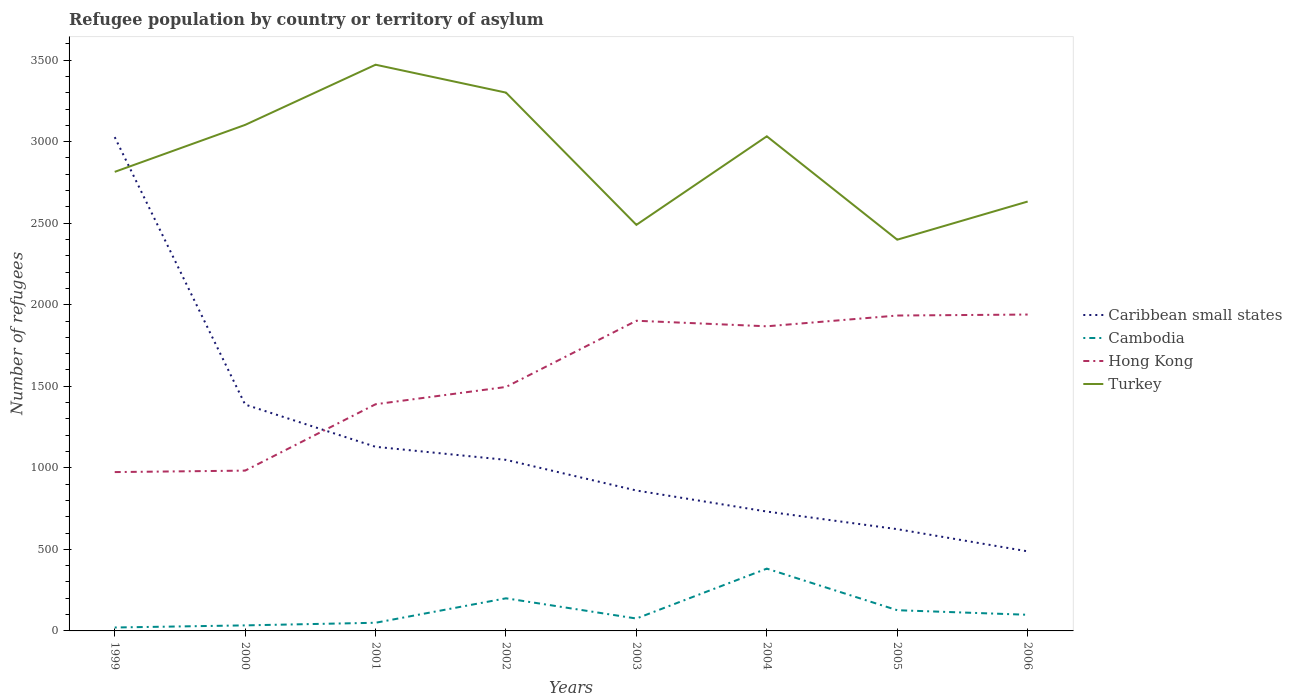Does the line corresponding to Turkey intersect with the line corresponding to Caribbean small states?
Offer a terse response. Yes. Is the number of lines equal to the number of legend labels?
Keep it short and to the point. Yes. Across all years, what is the maximum number of refugees in Cambodia?
Offer a terse response. 21. In which year was the number of refugees in Cambodia maximum?
Ensure brevity in your answer.  1999. What is the total number of refugees in Hong Kong in the graph?
Provide a succinct answer. -38. What is the difference between the highest and the second highest number of refugees in Cambodia?
Make the answer very short. 361. What is the difference between the highest and the lowest number of refugees in Hong Kong?
Give a very brief answer. 4. Is the number of refugees in Hong Kong strictly greater than the number of refugees in Caribbean small states over the years?
Give a very brief answer. No. How many lines are there?
Give a very brief answer. 4. How many years are there in the graph?
Keep it short and to the point. 8. How are the legend labels stacked?
Provide a succinct answer. Vertical. What is the title of the graph?
Your response must be concise. Refugee population by country or territory of asylum. What is the label or title of the X-axis?
Give a very brief answer. Years. What is the label or title of the Y-axis?
Ensure brevity in your answer.  Number of refugees. What is the Number of refugees of Caribbean small states in 1999?
Provide a short and direct response. 3028. What is the Number of refugees in Cambodia in 1999?
Your answer should be compact. 21. What is the Number of refugees of Hong Kong in 1999?
Ensure brevity in your answer.  974. What is the Number of refugees in Turkey in 1999?
Provide a succinct answer. 2815. What is the Number of refugees of Caribbean small states in 2000?
Provide a succinct answer. 1388. What is the Number of refugees in Hong Kong in 2000?
Keep it short and to the point. 983. What is the Number of refugees in Turkey in 2000?
Your response must be concise. 3103. What is the Number of refugees of Caribbean small states in 2001?
Ensure brevity in your answer.  1129. What is the Number of refugees of Hong Kong in 2001?
Give a very brief answer. 1390. What is the Number of refugees of Turkey in 2001?
Your answer should be very brief. 3472. What is the Number of refugees in Caribbean small states in 2002?
Provide a short and direct response. 1049. What is the Number of refugees in Hong Kong in 2002?
Your answer should be very brief. 1496. What is the Number of refugees of Turkey in 2002?
Provide a succinct answer. 3301. What is the Number of refugees of Caribbean small states in 2003?
Provide a short and direct response. 861. What is the Number of refugees in Cambodia in 2003?
Your answer should be very brief. 76. What is the Number of refugees of Hong Kong in 2003?
Provide a succinct answer. 1902. What is the Number of refugees in Turkey in 2003?
Offer a very short reply. 2490. What is the Number of refugees of Caribbean small states in 2004?
Your response must be concise. 732. What is the Number of refugees in Cambodia in 2004?
Keep it short and to the point. 382. What is the Number of refugees of Hong Kong in 2004?
Ensure brevity in your answer.  1868. What is the Number of refugees in Turkey in 2004?
Ensure brevity in your answer.  3033. What is the Number of refugees of Caribbean small states in 2005?
Your answer should be very brief. 624. What is the Number of refugees in Cambodia in 2005?
Give a very brief answer. 127. What is the Number of refugees in Hong Kong in 2005?
Offer a very short reply. 1934. What is the Number of refugees of Turkey in 2005?
Ensure brevity in your answer.  2399. What is the Number of refugees in Caribbean small states in 2006?
Provide a short and direct response. 488. What is the Number of refugees of Cambodia in 2006?
Provide a succinct answer. 99. What is the Number of refugees of Hong Kong in 2006?
Keep it short and to the point. 1940. What is the Number of refugees of Turkey in 2006?
Make the answer very short. 2633. Across all years, what is the maximum Number of refugees in Caribbean small states?
Provide a succinct answer. 3028. Across all years, what is the maximum Number of refugees of Cambodia?
Provide a short and direct response. 382. Across all years, what is the maximum Number of refugees of Hong Kong?
Offer a very short reply. 1940. Across all years, what is the maximum Number of refugees of Turkey?
Your response must be concise. 3472. Across all years, what is the minimum Number of refugees in Caribbean small states?
Ensure brevity in your answer.  488. Across all years, what is the minimum Number of refugees of Hong Kong?
Offer a terse response. 974. Across all years, what is the minimum Number of refugees of Turkey?
Give a very brief answer. 2399. What is the total Number of refugees of Caribbean small states in the graph?
Ensure brevity in your answer.  9299. What is the total Number of refugees in Cambodia in the graph?
Your answer should be very brief. 989. What is the total Number of refugees of Hong Kong in the graph?
Provide a succinct answer. 1.25e+04. What is the total Number of refugees in Turkey in the graph?
Your response must be concise. 2.32e+04. What is the difference between the Number of refugees in Caribbean small states in 1999 and that in 2000?
Offer a terse response. 1640. What is the difference between the Number of refugees in Hong Kong in 1999 and that in 2000?
Ensure brevity in your answer.  -9. What is the difference between the Number of refugees of Turkey in 1999 and that in 2000?
Provide a short and direct response. -288. What is the difference between the Number of refugees in Caribbean small states in 1999 and that in 2001?
Provide a short and direct response. 1899. What is the difference between the Number of refugees in Hong Kong in 1999 and that in 2001?
Your response must be concise. -416. What is the difference between the Number of refugees of Turkey in 1999 and that in 2001?
Make the answer very short. -657. What is the difference between the Number of refugees of Caribbean small states in 1999 and that in 2002?
Your response must be concise. 1979. What is the difference between the Number of refugees in Cambodia in 1999 and that in 2002?
Your answer should be compact. -179. What is the difference between the Number of refugees in Hong Kong in 1999 and that in 2002?
Your answer should be very brief. -522. What is the difference between the Number of refugees in Turkey in 1999 and that in 2002?
Your response must be concise. -486. What is the difference between the Number of refugees of Caribbean small states in 1999 and that in 2003?
Keep it short and to the point. 2167. What is the difference between the Number of refugees in Cambodia in 1999 and that in 2003?
Provide a succinct answer. -55. What is the difference between the Number of refugees of Hong Kong in 1999 and that in 2003?
Provide a succinct answer. -928. What is the difference between the Number of refugees of Turkey in 1999 and that in 2003?
Provide a short and direct response. 325. What is the difference between the Number of refugees of Caribbean small states in 1999 and that in 2004?
Provide a succinct answer. 2296. What is the difference between the Number of refugees of Cambodia in 1999 and that in 2004?
Your response must be concise. -361. What is the difference between the Number of refugees in Hong Kong in 1999 and that in 2004?
Provide a short and direct response. -894. What is the difference between the Number of refugees of Turkey in 1999 and that in 2004?
Keep it short and to the point. -218. What is the difference between the Number of refugees of Caribbean small states in 1999 and that in 2005?
Keep it short and to the point. 2404. What is the difference between the Number of refugees in Cambodia in 1999 and that in 2005?
Make the answer very short. -106. What is the difference between the Number of refugees in Hong Kong in 1999 and that in 2005?
Ensure brevity in your answer.  -960. What is the difference between the Number of refugees in Turkey in 1999 and that in 2005?
Offer a terse response. 416. What is the difference between the Number of refugees of Caribbean small states in 1999 and that in 2006?
Provide a short and direct response. 2540. What is the difference between the Number of refugees of Cambodia in 1999 and that in 2006?
Ensure brevity in your answer.  -78. What is the difference between the Number of refugees in Hong Kong in 1999 and that in 2006?
Give a very brief answer. -966. What is the difference between the Number of refugees of Turkey in 1999 and that in 2006?
Give a very brief answer. 182. What is the difference between the Number of refugees of Caribbean small states in 2000 and that in 2001?
Provide a succinct answer. 259. What is the difference between the Number of refugees in Cambodia in 2000 and that in 2001?
Give a very brief answer. -16. What is the difference between the Number of refugees in Hong Kong in 2000 and that in 2001?
Offer a very short reply. -407. What is the difference between the Number of refugees of Turkey in 2000 and that in 2001?
Provide a succinct answer. -369. What is the difference between the Number of refugees in Caribbean small states in 2000 and that in 2002?
Ensure brevity in your answer.  339. What is the difference between the Number of refugees of Cambodia in 2000 and that in 2002?
Your answer should be compact. -166. What is the difference between the Number of refugees in Hong Kong in 2000 and that in 2002?
Your response must be concise. -513. What is the difference between the Number of refugees in Turkey in 2000 and that in 2002?
Give a very brief answer. -198. What is the difference between the Number of refugees of Caribbean small states in 2000 and that in 2003?
Offer a terse response. 527. What is the difference between the Number of refugees of Cambodia in 2000 and that in 2003?
Your answer should be compact. -42. What is the difference between the Number of refugees of Hong Kong in 2000 and that in 2003?
Your answer should be compact. -919. What is the difference between the Number of refugees of Turkey in 2000 and that in 2003?
Offer a very short reply. 613. What is the difference between the Number of refugees in Caribbean small states in 2000 and that in 2004?
Provide a succinct answer. 656. What is the difference between the Number of refugees in Cambodia in 2000 and that in 2004?
Your answer should be very brief. -348. What is the difference between the Number of refugees of Hong Kong in 2000 and that in 2004?
Offer a terse response. -885. What is the difference between the Number of refugees of Turkey in 2000 and that in 2004?
Your answer should be compact. 70. What is the difference between the Number of refugees in Caribbean small states in 2000 and that in 2005?
Provide a short and direct response. 764. What is the difference between the Number of refugees in Cambodia in 2000 and that in 2005?
Your answer should be very brief. -93. What is the difference between the Number of refugees of Hong Kong in 2000 and that in 2005?
Your answer should be compact. -951. What is the difference between the Number of refugees in Turkey in 2000 and that in 2005?
Your answer should be compact. 704. What is the difference between the Number of refugees in Caribbean small states in 2000 and that in 2006?
Make the answer very short. 900. What is the difference between the Number of refugees in Cambodia in 2000 and that in 2006?
Ensure brevity in your answer.  -65. What is the difference between the Number of refugees of Hong Kong in 2000 and that in 2006?
Provide a short and direct response. -957. What is the difference between the Number of refugees of Turkey in 2000 and that in 2006?
Your answer should be very brief. 470. What is the difference between the Number of refugees of Cambodia in 2001 and that in 2002?
Your answer should be compact. -150. What is the difference between the Number of refugees of Hong Kong in 2001 and that in 2002?
Your answer should be very brief. -106. What is the difference between the Number of refugees of Turkey in 2001 and that in 2002?
Your answer should be compact. 171. What is the difference between the Number of refugees of Caribbean small states in 2001 and that in 2003?
Offer a terse response. 268. What is the difference between the Number of refugees of Cambodia in 2001 and that in 2003?
Provide a succinct answer. -26. What is the difference between the Number of refugees of Hong Kong in 2001 and that in 2003?
Provide a short and direct response. -512. What is the difference between the Number of refugees of Turkey in 2001 and that in 2003?
Make the answer very short. 982. What is the difference between the Number of refugees of Caribbean small states in 2001 and that in 2004?
Your response must be concise. 397. What is the difference between the Number of refugees of Cambodia in 2001 and that in 2004?
Your answer should be very brief. -332. What is the difference between the Number of refugees in Hong Kong in 2001 and that in 2004?
Provide a succinct answer. -478. What is the difference between the Number of refugees in Turkey in 2001 and that in 2004?
Ensure brevity in your answer.  439. What is the difference between the Number of refugees in Caribbean small states in 2001 and that in 2005?
Offer a terse response. 505. What is the difference between the Number of refugees in Cambodia in 2001 and that in 2005?
Keep it short and to the point. -77. What is the difference between the Number of refugees in Hong Kong in 2001 and that in 2005?
Offer a very short reply. -544. What is the difference between the Number of refugees in Turkey in 2001 and that in 2005?
Your answer should be compact. 1073. What is the difference between the Number of refugees of Caribbean small states in 2001 and that in 2006?
Provide a succinct answer. 641. What is the difference between the Number of refugees of Cambodia in 2001 and that in 2006?
Your answer should be compact. -49. What is the difference between the Number of refugees of Hong Kong in 2001 and that in 2006?
Your answer should be very brief. -550. What is the difference between the Number of refugees in Turkey in 2001 and that in 2006?
Keep it short and to the point. 839. What is the difference between the Number of refugees in Caribbean small states in 2002 and that in 2003?
Keep it short and to the point. 188. What is the difference between the Number of refugees of Cambodia in 2002 and that in 2003?
Offer a terse response. 124. What is the difference between the Number of refugees of Hong Kong in 2002 and that in 2003?
Provide a short and direct response. -406. What is the difference between the Number of refugees in Turkey in 2002 and that in 2003?
Offer a terse response. 811. What is the difference between the Number of refugees of Caribbean small states in 2002 and that in 2004?
Your answer should be compact. 317. What is the difference between the Number of refugees of Cambodia in 2002 and that in 2004?
Offer a terse response. -182. What is the difference between the Number of refugees of Hong Kong in 2002 and that in 2004?
Make the answer very short. -372. What is the difference between the Number of refugees in Turkey in 2002 and that in 2004?
Offer a terse response. 268. What is the difference between the Number of refugees in Caribbean small states in 2002 and that in 2005?
Make the answer very short. 425. What is the difference between the Number of refugees in Cambodia in 2002 and that in 2005?
Offer a terse response. 73. What is the difference between the Number of refugees in Hong Kong in 2002 and that in 2005?
Keep it short and to the point. -438. What is the difference between the Number of refugees of Turkey in 2002 and that in 2005?
Offer a terse response. 902. What is the difference between the Number of refugees in Caribbean small states in 2002 and that in 2006?
Your answer should be very brief. 561. What is the difference between the Number of refugees of Cambodia in 2002 and that in 2006?
Provide a succinct answer. 101. What is the difference between the Number of refugees of Hong Kong in 2002 and that in 2006?
Keep it short and to the point. -444. What is the difference between the Number of refugees of Turkey in 2002 and that in 2006?
Offer a terse response. 668. What is the difference between the Number of refugees in Caribbean small states in 2003 and that in 2004?
Offer a terse response. 129. What is the difference between the Number of refugees of Cambodia in 2003 and that in 2004?
Your response must be concise. -306. What is the difference between the Number of refugees of Turkey in 2003 and that in 2004?
Ensure brevity in your answer.  -543. What is the difference between the Number of refugees in Caribbean small states in 2003 and that in 2005?
Provide a short and direct response. 237. What is the difference between the Number of refugees in Cambodia in 2003 and that in 2005?
Provide a succinct answer. -51. What is the difference between the Number of refugees of Hong Kong in 2003 and that in 2005?
Your answer should be compact. -32. What is the difference between the Number of refugees of Turkey in 2003 and that in 2005?
Offer a very short reply. 91. What is the difference between the Number of refugees of Caribbean small states in 2003 and that in 2006?
Keep it short and to the point. 373. What is the difference between the Number of refugees in Hong Kong in 2003 and that in 2006?
Your response must be concise. -38. What is the difference between the Number of refugees in Turkey in 2003 and that in 2006?
Offer a very short reply. -143. What is the difference between the Number of refugees in Caribbean small states in 2004 and that in 2005?
Your response must be concise. 108. What is the difference between the Number of refugees of Cambodia in 2004 and that in 2005?
Offer a very short reply. 255. What is the difference between the Number of refugees of Hong Kong in 2004 and that in 2005?
Make the answer very short. -66. What is the difference between the Number of refugees in Turkey in 2004 and that in 2005?
Ensure brevity in your answer.  634. What is the difference between the Number of refugees of Caribbean small states in 2004 and that in 2006?
Give a very brief answer. 244. What is the difference between the Number of refugees in Cambodia in 2004 and that in 2006?
Provide a short and direct response. 283. What is the difference between the Number of refugees in Hong Kong in 2004 and that in 2006?
Keep it short and to the point. -72. What is the difference between the Number of refugees of Caribbean small states in 2005 and that in 2006?
Offer a terse response. 136. What is the difference between the Number of refugees of Turkey in 2005 and that in 2006?
Provide a short and direct response. -234. What is the difference between the Number of refugees of Caribbean small states in 1999 and the Number of refugees of Cambodia in 2000?
Keep it short and to the point. 2994. What is the difference between the Number of refugees in Caribbean small states in 1999 and the Number of refugees in Hong Kong in 2000?
Provide a succinct answer. 2045. What is the difference between the Number of refugees of Caribbean small states in 1999 and the Number of refugees of Turkey in 2000?
Your answer should be compact. -75. What is the difference between the Number of refugees of Cambodia in 1999 and the Number of refugees of Hong Kong in 2000?
Keep it short and to the point. -962. What is the difference between the Number of refugees of Cambodia in 1999 and the Number of refugees of Turkey in 2000?
Give a very brief answer. -3082. What is the difference between the Number of refugees in Hong Kong in 1999 and the Number of refugees in Turkey in 2000?
Your answer should be compact. -2129. What is the difference between the Number of refugees in Caribbean small states in 1999 and the Number of refugees in Cambodia in 2001?
Offer a terse response. 2978. What is the difference between the Number of refugees in Caribbean small states in 1999 and the Number of refugees in Hong Kong in 2001?
Your answer should be very brief. 1638. What is the difference between the Number of refugees of Caribbean small states in 1999 and the Number of refugees of Turkey in 2001?
Keep it short and to the point. -444. What is the difference between the Number of refugees of Cambodia in 1999 and the Number of refugees of Hong Kong in 2001?
Offer a terse response. -1369. What is the difference between the Number of refugees in Cambodia in 1999 and the Number of refugees in Turkey in 2001?
Provide a succinct answer. -3451. What is the difference between the Number of refugees in Hong Kong in 1999 and the Number of refugees in Turkey in 2001?
Offer a very short reply. -2498. What is the difference between the Number of refugees of Caribbean small states in 1999 and the Number of refugees of Cambodia in 2002?
Your answer should be very brief. 2828. What is the difference between the Number of refugees in Caribbean small states in 1999 and the Number of refugees in Hong Kong in 2002?
Provide a succinct answer. 1532. What is the difference between the Number of refugees of Caribbean small states in 1999 and the Number of refugees of Turkey in 2002?
Ensure brevity in your answer.  -273. What is the difference between the Number of refugees of Cambodia in 1999 and the Number of refugees of Hong Kong in 2002?
Provide a succinct answer. -1475. What is the difference between the Number of refugees in Cambodia in 1999 and the Number of refugees in Turkey in 2002?
Your answer should be compact. -3280. What is the difference between the Number of refugees in Hong Kong in 1999 and the Number of refugees in Turkey in 2002?
Give a very brief answer. -2327. What is the difference between the Number of refugees of Caribbean small states in 1999 and the Number of refugees of Cambodia in 2003?
Provide a short and direct response. 2952. What is the difference between the Number of refugees in Caribbean small states in 1999 and the Number of refugees in Hong Kong in 2003?
Your answer should be very brief. 1126. What is the difference between the Number of refugees in Caribbean small states in 1999 and the Number of refugees in Turkey in 2003?
Provide a short and direct response. 538. What is the difference between the Number of refugees of Cambodia in 1999 and the Number of refugees of Hong Kong in 2003?
Provide a succinct answer. -1881. What is the difference between the Number of refugees in Cambodia in 1999 and the Number of refugees in Turkey in 2003?
Keep it short and to the point. -2469. What is the difference between the Number of refugees in Hong Kong in 1999 and the Number of refugees in Turkey in 2003?
Provide a short and direct response. -1516. What is the difference between the Number of refugees in Caribbean small states in 1999 and the Number of refugees in Cambodia in 2004?
Give a very brief answer. 2646. What is the difference between the Number of refugees in Caribbean small states in 1999 and the Number of refugees in Hong Kong in 2004?
Keep it short and to the point. 1160. What is the difference between the Number of refugees in Caribbean small states in 1999 and the Number of refugees in Turkey in 2004?
Provide a succinct answer. -5. What is the difference between the Number of refugees of Cambodia in 1999 and the Number of refugees of Hong Kong in 2004?
Provide a short and direct response. -1847. What is the difference between the Number of refugees of Cambodia in 1999 and the Number of refugees of Turkey in 2004?
Provide a short and direct response. -3012. What is the difference between the Number of refugees in Hong Kong in 1999 and the Number of refugees in Turkey in 2004?
Make the answer very short. -2059. What is the difference between the Number of refugees in Caribbean small states in 1999 and the Number of refugees in Cambodia in 2005?
Keep it short and to the point. 2901. What is the difference between the Number of refugees of Caribbean small states in 1999 and the Number of refugees of Hong Kong in 2005?
Ensure brevity in your answer.  1094. What is the difference between the Number of refugees of Caribbean small states in 1999 and the Number of refugees of Turkey in 2005?
Make the answer very short. 629. What is the difference between the Number of refugees in Cambodia in 1999 and the Number of refugees in Hong Kong in 2005?
Offer a very short reply. -1913. What is the difference between the Number of refugees in Cambodia in 1999 and the Number of refugees in Turkey in 2005?
Your answer should be compact. -2378. What is the difference between the Number of refugees of Hong Kong in 1999 and the Number of refugees of Turkey in 2005?
Give a very brief answer. -1425. What is the difference between the Number of refugees of Caribbean small states in 1999 and the Number of refugees of Cambodia in 2006?
Give a very brief answer. 2929. What is the difference between the Number of refugees of Caribbean small states in 1999 and the Number of refugees of Hong Kong in 2006?
Your response must be concise. 1088. What is the difference between the Number of refugees of Caribbean small states in 1999 and the Number of refugees of Turkey in 2006?
Offer a very short reply. 395. What is the difference between the Number of refugees of Cambodia in 1999 and the Number of refugees of Hong Kong in 2006?
Keep it short and to the point. -1919. What is the difference between the Number of refugees of Cambodia in 1999 and the Number of refugees of Turkey in 2006?
Your answer should be very brief. -2612. What is the difference between the Number of refugees in Hong Kong in 1999 and the Number of refugees in Turkey in 2006?
Offer a terse response. -1659. What is the difference between the Number of refugees in Caribbean small states in 2000 and the Number of refugees in Cambodia in 2001?
Your answer should be very brief. 1338. What is the difference between the Number of refugees of Caribbean small states in 2000 and the Number of refugees of Hong Kong in 2001?
Your answer should be very brief. -2. What is the difference between the Number of refugees in Caribbean small states in 2000 and the Number of refugees in Turkey in 2001?
Your answer should be compact. -2084. What is the difference between the Number of refugees of Cambodia in 2000 and the Number of refugees of Hong Kong in 2001?
Offer a very short reply. -1356. What is the difference between the Number of refugees in Cambodia in 2000 and the Number of refugees in Turkey in 2001?
Make the answer very short. -3438. What is the difference between the Number of refugees of Hong Kong in 2000 and the Number of refugees of Turkey in 2001?
Ensure brevity in your answer.  -2489. What is the difference between the Number of refugees of Caribbean small states in 2000 and the Number of refugees of Cambodia in 2002?
Your answer should be compact. 1188. What is the difference between the Number of refugees in Caribbean small states in 2000 and the Number of refugees in Hong Kong in 2002?
Offer a terse response. -108. What is the difference between the Number of refugees in Caribbean small states in 2000 and the Number of refugees in Turkey in 2002?
Keep it short and to the point. -1913. What is the difference between the Number of refugees of Cambodia in 2000 and the Number of refugees of Hong Kong in 2002?
Offer a terse response. -1462. What is the difference between the Number of refugees in Cambodia in 2000 and the Number of refugees in Turkey in 2002?
Ensure brevity in your answer.  -3267. What is the difference between the Number of refugees in Hong Kong in 2000 and the Number of refugees in Turkey in 2002?
Your answer should be very brief. -2318. What is the difference between the Number of refugees in Caribbean small states in 2000 and the Number of refugees in Cambodia in 2003?
Make the answer very short. 1312. What is the difference between the Number of refugees of Caribbean small states in 2000 and the Number of refugees of Hong Kong in 2003?
Offer a very short reply. -514. What is the difference between the Number of refugees of Caribbean small states in 2000 and the Number of refugees of Turkey in 2003?
Ensure brevity in your answer.  -1102. What is the difference between the Number of refugees of Cambodia in 2000 and the Number of refugees of Hong Kong in 2003?
Keep it short and to the point. -1868. What is the difference between the Number of refugees of Cambodia in 2000 and the Number of refugees of Turkey in 2003?
Your response must be concise. -2456. What is the difference between the Number of refugees of Hong Kong in 2000 and the Number of refugees of Turkey in 2003?
Your response must be concise. -1507. What is the difference between the Number of refugees of Caribbean small states in 2000 and the Number of refugees of Cambodia in 2004?
Keep it short and to the point. 1006. What is the difference between the Number of refugees in Caribbean small states in 2000 and the Number of refugees in Hong Kong in 2004?
Ensure brevity in your answer.  -480. What is the difference between the Number of refugees of Caribbean small states in 2000 and the Number of refugees of Turkey in 2004?
Make the answer very short. -1645. What is the difference between the Number of refugees in Cambodia in 2000 and the Number of refugees in Hong Kong in 2004?
Keep it short and to the point. -1834. What is the difference between the Number of refugees in Cambodia in 2000 and the Number of refugees in Turkey in 2004?
Your response must be concise. -2999. What is the difference between the Number of refugees in Hong Kong in 2000 and the Number of refugees in Turkey in 2004?
Provide a short and direct response. -2050. What is the difference between the Number of refugees of Caribbean small states in 2000 and the Number of refugees of Cambodia in 2005?
Give a very brief answer. 1261. What is the difference between the Number of refugees in Caribbean small states in 2000 and the Number of refugees in Hong Kong in 2005?
Give a very brief answer. -546. What is the difference between the Number of refugees in Caribbean small states in 2000 and the Number of refugees in Turkey in 2005?
Provide a short and direct response. -1011. What is the difference between the Number of refugees of Cambodia in 2000 and the Number of refugees of Hong Kong in 2005?
Make the answer very short. -1900. What is the difference between the Number of refugees of Cambodia in 2000 and the Number of refugees of Turkey in 2005?
Give a very brief answer. -2365. What is the difference between the Number of refugees in Hong Kong in 2000 and the Number of refugees in Turkey in 2005?
Offer a very short reply. -1416. What is the difference between the Number of refugees of Caribbean small states in 2000 and the Number of refugees of Cambodia in 2006?
Give a very brief answer. 1289. What is the difference between the Number of refugees of Caribbean small states in 2000 and the Number of refugees of Hong Kong in 2006?
Ensure brevity in your answer.  -552. What is the difference between the Number of refugees of Caribbean small states in 2000 and the Number of refugees of Turkey in 2006?
Make the answer very short. -1245. What is the difference between the Number of refugees in Cambodia in 2000 and the Number of refugees in Hong Kong in 2006?
Offer a terse response. -1906. What is the difference between the Number of refugees of Cambodia in 2000 and the Number of refugees of Turkey in 2006?
Your answer should be compact. -2599. What is the difference between the Number of refugees of Hong Kong in 2000 and the Number of refugees of Turkey in 2006?
Make the answer very short. -1650. What is the difference between the Number of refugees of Caribbean small states in 2001 and the Number of refugees of Cambodia in 2002?
Make the answer very short. 929. What is the difference between the Number of refugees in Caribbean small states in 2001 and the Number of refugees in Hong Kong in 2002?
Give a very brief answer. -367. What is the difference between the Number of refugees in Caribbean small states in 2001 and the Number of refugees in Turkey in 2002?
Offer a very short reply. -2172. What is the difference between the Number of refugees in Cambodia in 2001 and the Number of refugees in Hong Kong in 2002?
Make the answer very short. -1446. What is the difference between the Number of refugees of Cambodia in 2001 and the Number of refugees of Turkey in 2002?
Provide a short and direct response. -3251. What is the difference between the Number of refugees of Hong Kong in 2001 and the Number of refugees of Turkey in 2002?
Your answer should be compact. -1911. What is the difference between the Number of refugees of Caribbean small states in 2001 and the Number of refugees of Cambodia in 2003?
Give a very brief answer. 1053. What is the difference between the Number of refugees in Caribbean small states in 2001 and the Number of refugees in Hong Kong in 2003?
Your answer should be very brief. -773. What is the difference between the Number of refugees in Caribbean small states in 2001 and the Number of refugees in Turkey in 2003?
Provide a succinct answer. -1361. What is the difference between the Number of refugees of Cambodia in 2001 and the Number of refugees of Hong Kong in 2003?
Give a very brief answer. -1852. What is the difference between the Number of refugees of Cambodia in 2001 and the Number of refugees of Turkey in 2003?
Provide a short and direct response. -2440. What is the difference between the Number of refugees of Hong Kong in 2001 and the Number of refugees of Turkey in 2003?
Provide a short and direct response. -1100. What is the difference between the Number of refugees in Caribbean small states in 2001 and the Number of refugees in Cambodia in 2004?
Give a very brief answer. 747. What is the difference between the Number of refugees in Caribbean small states in 2001 and the Number of refugees in Hong Kong in 2004?
Offer a very short reply. -739. What is the difference between the Number of refugees in Caribbean small states in 2001 and the Number of refugees in Turkey in 2004?
Your answer should be compact. -1904. What is the difference between the Number of refugees of Cambodia in 2001 and the Number of refugees of Hong Kong in 2004?
Provide a succinct answer. -1818. What is the difference between the Number of refugees of Cambodia in 2001 and the Number of refugees of Turkey in 2004?
Your response must be concise. -2983. What is the difference between the Number of refugees of Hong Kong in 2001 and the Number of refugees of Turkey in 2004?
Your answer should be compact. -1643. What is the difference between the Number of refugees in Caribbean small states in 2001 and the Number of refugees in Cambodia in 2005?
Your response must be concise. 1002. What is the difference between the Number of refugees in Caribbean small states in 2001 and the Number of refugees in Hong Kong in 2005?
Give a very brief answer. -805. What is the difference between the Number of refugees of Caribbean small states in 2001 and the Number of refugees of Turkey in 2005?
Your answer should be compact. -1270. What is the difference between the Number of refugees in Cambodia in 2001 and the Number of refugees in Hong Kong in 2005?
Your answer should be very brief. -1884. What is the difference between the Number of refugees in Cambodia in 2001 and the Number of refugees in Turkey in 2005?
Offer a terse response. -2349. What is the difference between the Number of refugees of Hong Kong in 2001 and the Number of refugees of Turkey in 2005?
Keep it short and to the point. -1009. What is the difference between the Number of refugees in Caribbean small states in 2001 and the Number of refugees in Cambodia in 2006?
Your answer should be compact. 1030. What is the difference between the Number of refugees of Caribbean small states in 2001 and the Number of refugees of Hong Kong in 2006?
Give a very brief answer. -811. What is the difference between the Number of refugees of Caribbean small states in 2001 and the Number of refugees of Turkey in 2006?
Make the answer very short. -1504. What is the difference between the Number of refugees of Cambodia in 2001 and the Number of refugees of Hong Kong in 2006?
Provide a short and direct response. -1890. What is the difference between the Number of refugees of Cambodia in 2001 and the Number of refugees of Turkey in 2006?
Give a very brief answer. -2583. What is the difference between the Number of refugees of Hong Kong in 2001 and the Number of refugees of Turkey in 2006?
Provide a short and direct response. -1243. What is the difference between the Number of refugees in Caribbean small states in 2002 and the Number of refugees in Cambodia in 2003?
Your answer should be compact. 973. What is the difference between the Number of refugees in Caribbean small states in 2002 and the Number of refugees in Hong Kong in 2003?
Provide a succinct answer. -853. What is the difference between the Number of refugees in Caribbean small states in 2002 and the Number of refugees in Turkey in 2003?
Provide a short and direct response. -1441. What is the difference between the Number of refugees of Cambodia in 2002 and the Number of refugees of Hong Kong in 2003?
Ensure brevity in your answer.  -1702. What is the difference between the Number of refugees of Cambodia in 2002 and the Number of refugees of Turkey in 2003?
Provide a succinct answer. -2290. What is the difference between the Number of refugees of Hong Kong in 2002 and the Number of refugees of Turkey in 2003?
Provide a short and direct response. -994. What is the difference between the Number of refugees of Caribbean small states in 2002 and the Number of refugees of Cambodia in 2004?
Keep it short and to the point. 667. What is the difference between the Number of refugees in Caribbean small states in 2002 and the Number of refugees in Hong Kong in 2004?
Your response must be concise. -819. What is the difference between the Number of refugees of Caribbean small states in 2002 and the Number of refugees of Turkey in 2004?
Your answer should be compact. -1984. What is the difference between the Number of refugees in Cambodia in 2002 and the Number of refugees in Hong Kong in 2004?
Offer a very short reply. -1668. What is the difference between the Number of refugees in Cambodia in 2002 and the Number of refugees in Turkey in 2004?
Make the answer very short. -2833. What is the difference between the Number of refugees of Hong Kong in 2002 and the Number of refugees of Turkey in 2004?
Offer a very short reply. -1537. What is the difference between the Number of refugees of Caribbean small states in 2002 and the Number of refugees of Cambodia in 2005?
Keep it short and to the point. 922. What is the difference between the Number of refugees in Caribbean small states in 2002 and the Number of refugees in Hong Kong in 2005?
Offer a very short reply. -885. What is the difference between the Number of refugees in Caribbean small states in 2002 and the Number of refugees in Turkey in 2005?
Provide a succinct answer. -1350. What is the difference between the Number of refugees in Cambodia in 2002 and the Number of refugees in Hong Kong in 2005?
Your response must be concise. -1734. What is the difference between the Number of refugees in Cambodia in 2002 and the Number of refugees in Turkey in 2005?
Provide a short and direct response. -2199. What is the difference between the Number of refugees in Hong Kong in 2002 and the Number of refugees in Turkey in 2005?
Give a very brief answer. -903. What is the difference between the Number of refugees of Caribbean small states in 2002 and the Number of refugees of Cambodia in 2006?
Ensure brevity in your answer.  950. What is the difference between the Number of refugees of Caribbean small states in 2002 and the Number of refugees of Hong Kong in 2006?
Your response must be concise. -891. What is the difference between the Number of refugees in Caribbean small states in 2002 and the Number of refugees in Turkey in 2006?
Your response must be concise. -1584. What is the difference between the Number of refugees in Cambodia in 2002 and the Number of refugees in Hong Kong in 2006?
Provide a short and direct response. -1740. What is the difference between the Number of refugees of Cambodia in 2002 and the Number of refugees of Turkey in 2006?
Make the answer very short. -2433. What is the difference between the Number of refugees of Hong Kong in 2002 and the Number of refugees of Turkey in 2006?
Offer a terse response. -1137. What is the difference between the Number of refugees of Caribbean small states in 2003 and the Number of refugees of Cambodia in 2004?
Ensure brevity in your answer.  479. What is the difference between the Number of refugees of Caribbean small states in 2003 and the Number of refugees of Hong Kong in 2004?
Keep it short and to the point. -1007. What is the difference between the Number of refugees of Caribbean small states in 2003 and the Number of refugees of Turkey in 2004?
Provide a short and direct response. -2172. What is the difference between the Number of refugees in Cambodia in 2003 and the Number of refugees in Hong Kong in 2004?
Your response must be concise. -1792. What is the difference between the Number of refugees of Cambodia in 2003 and the Number of refugees of Turkey in 2004?
Give a very brief answer. -2957. What is the difference between the Number of refugees of Hong Kong in 2003 and the Number of refugees of Turkey in 2004?
Your answer should be very brief. -1131. What is the difference between the Number of refugees of Caribbean small states in 2003 and the Number of refugees of Cambodia in 2005?
Your response must be concise. 734. What is the difference between the Number of refugees of Caribbean small states in 2003 and the Number of refugees of Hong Kong in 2005?
Provide a succinct answer. -1073. What is the difference between the Number of refugees in Caribbean small states in 2003 and the Number of refugees in Turkey in 2005?
Give a very brief answer. -1538. What is the difference between the Number of refugees in Cambodia in 2003 and the Number of refugees in Hong Kong in 2005?
Your answer should be very brief. -1858. What is the difference between the Number of refugees in Cambodia in 2003 and the Number of refugees in Turkey in 2005?
Your answer should be very brief. -2323. What is the difference between the Number of refugees in Hong Kong in 2003 and the Number of refugees in Turkey in 2005?
Your answer should be compact. -497. What is the difference between the Number of refugees in Caribbean small states in 2003 and the Number of refugees in Cambodia in 2006?
Make the answer very short. 762. What is the difference between the Number of refugees of Caribbean small states in 2003 and the Number of refugees of Hong Kong in 2006?
Provide a succinct answer. -1079. What is the difference between the Number of refugees of Caribbean small states in 2003 and the Number of refugees of Turkey in 2006?
Your response must be concise. -1772. What is the difference between the Number of refugees in Cambodia in 2003 and the Number of refugees in Hong Kong in 2006?
Provide a succinct answer. -1864. What is the difference between the Number of refugees in Cambodia in 2003 and the Number of refugees in Turkey in 2006?
Make the answer very short. -2557. What is the difference between the Number of refugees of Hong Kong in 2003 and the Number of refugees of Turkey in 2006?
Offer a very short reply. -731. What is the difference between the Number of refugees in Caribbean small states in 2004 and the Number of refugees in Cambodia in 2005?
Provide a succinct answer. 605. What is the difference between the Number of refugees of Caribbean small states in 2004 and the Number of refugees of Hong Kong in 2005?
Ensure brevity in your answer.  -1202. What is the difference between the Number of refugees in Caribbean small states in 2004 and the Number of refugees in Turkey in 2005?
Offer a terse response. -1667. What is the difference between the Number of refugees of Cambodia in 2004 and the Number of refugees of Hong Kong in 2005?
Offer a very short reply. -1552. What is the difference between the Number of refugees in Cambodia in 2004 and the Number of refugees in Turkey in 2005?
Ensure brevity in your answer.  -2017. What is the difference between the Number of refugees in Hong Kong in 2004 and the Number of refugees in Turkey in 2005?
Provide a short and direct response. -531. What is the difference between the Number of refugees in Caribbean small states in 2004 and the Number of refugees in Cambodia in 2006?
Your answer should be very brief. 633. What is the difference between the Number of refugees in Caribbean small states in 2004 and the Number of refugees in Hong Kong in 2006?
Offer a very short reply. -1208. What is the difference between the Number of refugees in Caribbean small states in 2004 and the Number of refugees in Turkey in 2006?
Your response must be concise. -1901. What is the difference between the Number of refugees of Cambodia in 2004 and the Number of refugees of Hong Kong in 2006?
Ensure brevity in your answer.  -1558. What is the difference between the Number of refugees of Cambodia in 2004 and the Number of refugees of Turkey in 2006?
Your response must be concise. -2251. What is the difference between the Number of refugees in Hong Kong in 2004 and the Number of refugees in Turkey in 2006?
Keep it short and to the point. -765. What is the difference between the Number of refugees in Caribbean small states in 2005 and the Number of refugees in Cambodia in 2006?
Make the answer very short. 525. What is the difference between the Number of refugees of Caribbean small states in 2005 and the Number of refugees of Hong Kong in 2006?
Give a very brief answer. -1316. What is the difference between the Number of refugees of Caribbean small states in 2005 and the Number of refugees of Turkey in 2006?
Your answer should be compact. -2009. What is the difference between the Number of refugees in Cambodia in 2005 and the Number of refugees in Hong Kong in 2006?
Your answer should be compact. -1813. What is the difference between the Number of refugees of Cambodia in 2005 and the Number of refugees of Turkey in 2006?
Make the answer very short. -2506. What is the difference between the Number of refugees of Hong Kong in 2005 and the Number of refugees of Turkey in 2006?
Make the answer very short. -699. What is the average Number of refugees of Caribbean small states per year?
Give a very brief answer. 1162.38. What is the average Number of refugees in Cambodia per year?
Make the answer very short. 123.62. What is the average Number of refugees of Hong Kong per year?
Your response must be concise. 1560.88. What is the average Number of refugees of Turkey per year?
Ensure brevity in your answer.  2905.75. In the year 1999, what is the difference between the Number of refugees in Caribbean small states and Number of refugees in Cambodia?
Offer a terse response. 3007. In the year 1999, what is the difference between the Number of refugees of Caribbean small states and Number of refugees of Hong Kong?
Ensure brevity in your answer.  2054. In the year 1999, what is the difference between the Number of refugees of Caribbean small states and Number of refugees of Turkey?
Keep it short and to the point. 213. In the year 1999, what is the difference between the Number of refugees in Cambodia and Number of refugees in Hong Kong?
Your answer should be very brief. -953. In the year 1999, what is the difference between the Number of refugees of Cambodia and Number of refugees of Turkey?
Give a very brief answer. -2794. In the year 1999, what is the difference between the Number of refugees of Hong Kong and Number of refugees of Turkey?
Your answer should be very brief. -1841. In the year 2000, what is the difference between the Number of refugees in Caribbean small states and Number of refugees in Cambodia?
Provide a succinct answer. 1354. In the year 2000, what is the difference between the Number of refugees in Caribbean small states and Number of refugees in Hong Kong?
Ensure brevity in your answer.  405. In the year 2000, what is the difference between the Number of refugees of Caribbean small states and Number of refugees of Turkey?
Your answer should be compact. -1715. In the year 2000, what is the difference between the Number of refugees in Cambodia and Number of refugees in Hong Kong?
Your response must be concise. -949. In the year 2000, what is the difference between the Number of refugees in Cambodia and Number of refugees in Turkey?
Ensure brevity in your answer.  -3069. In the year 2000, what is the difference between the Number of refugees of Hong Kong and Number of refugees of Turkey?
Your response must be concise. -2120. In the year 2001, what is the difference between the Number of refugees in Caribbean small states and Number of refugees in Cambodia?
Your answer should be compact. 1079. In the year 2001, what is the difference between the Number of refugees in Caribbean small states and Number of refugees in Hong Kong?
Your response must be concise. -261. In the year 2001, what is the difference between the Number of refugees in Caribbean small states and Number of refugees in Turkey?
Your response must be concise. -2343. In the year 2001, what is the difference between the Number of refugees of Cambodia and Number of refugees of Hong Kong?
Your response must be concise. -1340. In the year 2001, what is the difference between the Number of refugees of Cambodia and Number of refugees of Turkey?
Ensure brevity in your answer.  -3422. In the year 2001, what is the difference between the Number of refugees of Hong Kong and Number of refugees of Turkey?
Your response must be concise. -2082. In the year 2002, what is the difference between the Number of refugees of Caribbean small states and Number of refugees of Cambodia?
Ensure brevity in your answer.  849. In the year 2002, what is the difference between the Number of refugees of Caribbean small states and Number of refugees of Hong Kong?
Provide a succinct answer. -447. In the year 2002, what is the difference between the Number of refugees of Caribbean small states and Number of refugees of Turkey?
Your response must be concise. -2252. In the year 2002, what is the difference between the Number of refugees of Cambodia and Number of refugees of Hong Kong?
Provide a succinct answer. -1296. In the year 2002, what is the difference between the Number of refugees of Cambodia and Number of refugees of Turkey?
Your response must be concise. -3101. In the year 2002, what is the difference between the Number of refugees of Hong Kong and Number of refugees of Turkey?
Your response must be concise. -1805. In the year 2003, what is the difference between the Number of refugees of Caribbean small states and Number of refugees of Cambodia?
Keep it short and to the point. 785. In the year 2003, what is the difference between the Number of refugees in Caribbean small states and Number of refugees in Hong Kong?
Provide a succinct answer. -1041. In the year 2003, what is the difference between the Number of refugees in Caribbean small states and Number of refugees in Turkey?
Your response must be concise. -1629. In the year 2003, what is the difference between the Number of refugees of Cambodia and Number of refugees of Hong Kong?
Keep it short and to the point. -1826. In the year 2003, what is the difference between the Number of refugees in Cambodia and Number of refugees in Turkey?
Your answer should be very brief. -2414. In the year 2003, what is the difference between the Number of refugees in Hong Kong and Number of refugees in Turkey?
Provide a short and direct response. -588. In the year 2004, what is the difference between the Number of refugees in Caribbean small states and Number of refugees in Cambodia?
Your answer should be very brief. 350. In the year 2004, what is the difference between the Number of refugees in Caribbean small states and Number of refugees in Hong Kong?
Your answer should be very brief. -1136. In the year 2004, what is the difference between the Number of refugees in Caribbean small states and Number of refugees in Turkey?
Ensure brevity in your answer.  -2301. In the year 2004, what is the difference between the Number of refugees in Cambodia and Number of refugees in Hong Kong?
Offer a terse response. -1486. In the year 2004, what is the difference between the Number of refugees in Cambodia and Number of refugees in Turkey?
Ensure brevity in your answer.  -2651. In the year 2004, what is the difference between the Number of refugees of Hong Kong and Number of refugees of Turkey?
Make the answer very short. -1165. In the year 2005, what is the difference between the Number of refugees in Caribbean small states and Number of refugees in Cambodia?
Keep it short and to the point. 497. In the year 2005, what is the difference between the Number of refugees of Caribbean small states and Number of refugees of Hong Kong?
Keep it short and to the point. -1310. In the year 2005, what is the difference between the Number of refugees in Caribbean small states and Number of refugees in Turkey?
Your response must be concise. -1775. In the year 2005, what is the difference between the Number of refugees in Cambodia and Number of refugees in Hong Kong?
Ensure brevity in your answer.  -1807. In the year 2005, what is the difference between the Number of refugees of Cambodia and Number of refugees of Turkey?
Give a very brief answer. -2272. In the year 2005, what is the difference between the Number of refugees in Hong Kong and Number of refugees in Turkey?
Give a very brief answer. -465. In the year 2006, what is the difference between the Number of refugees in Caribbean small states and Number of refugees in Cambodia?
Keep it short and to the point. 389. In the year 2006, what is the difference between the Number of refugees of Caribbean small states and Number of refugees of Hong Kong?
Keep it short and to the point. -1452. In the year 2006, what is the difference between the Number of refugees of Caribbean small states and Number of refugees of Turkey?
Keep it short and to the point. -2145. In the year 2006, what is the difference between the Number of refugees in Cambodia and Number of refugees in Hong Kong?
Make the answer very short. -1841. In the year 2006, what is the difference between the Number of refugees of Cambodia and Number of refugees of Turkey?
Give a very brief answer. -2534. In the year 2006, what is the difference between the Number of refugees in Hong Kong and Number of refugees in Turkey?
Offer a very short reply. -693. What is the ratio of the Number of refugees of Caribbean small states in 1999 to that in 2000?
Give a very brief answer. 2.18. What is the ratio of the Number of refugees of Cambodia in 1999 to that in 2000?
Ensure brevity in your answer.  0.62. What is the ratio of the Number of refugees of Turkey in 1999 to that in 2000?
Offer a terse response. 0.91. What is the ratio of the Number of refugees in Caribbean small states in 1999 to that in 2001?
Your response must be concise. 2.68. What is the ratio of the Number of refugees in Cambodia in 1999 to that in 2001?
Provide a short and direct response. 0.42. What is the ratio of the Number of refugees of Hong Kong in 1999 to that in 2001?
Ensure brevity in your answer.  0.7. What is the ratio of the Number of refugees in Turkey in 1999 to that in 2001?
Provide a short and direct response. 0.81. What is the ratio of the Number of refugees of Caribbean small states in 1999 to that in 2002?
Keep it short and to the point. 2.89. What is the ratio of the Number of refugees in Cambodia in 1999 to that in 2002?
Make the answer very short. 0.1. What is the ratio of the Number of refugees of Hong Kong in 1999 to that in 2002?
Your answer should be compact. 0.65. What is the ratio of the Number of refugees in Turkey in 1999 to that in 2002?
Your response must be concise. 0.85. What is the ratio of the Number of refugees in Caribbean small states in 1999 to that in 2003?
Give a very brief answer. 3.52. What is the ratio of the Number of refugees of Cambodia in 1999 to that in 2003?
Give a very brief answer. 0.28. What is the ratio of the Number of refugees of Hong Kong in 1999 to that in 2003?
Your response must be concise. 0.51. What is the ratio of the Number of refugees of Turkey in 1999 to that in 2003?
Give a very brief answer. 1.13. What is the ratio of the Number of refugees in Caribbean small states in 1999 to that in 2004?
Provide a short and direct response. 4.14. What is the ratio of the Number of refugees of Cambodia in 1999 to that in 2004?
Your answer should be very brief. 0.06. What is the ratio of the Number of refugees in Hong Kong in 1999 to that in 2004?
Keep it short and to the point. 0.52. What is the ratio of the Number of refugees in Turkey in 1999 to that in 2004?
Ensure brevity in your answer.  0.93. What is the ratio of the Number of refugees in Caribbean small states in 1999 to that in 2005?
Ensure brevity in your answer.  4.85. What is the ratio of the Number of refugees of Cambodia in 1999 to that in 2005?
Keep it short and to the point. 0.17. What is the ratio of the Number of refugees in Hong Kong in 1999 to that in 2005?
Give a very brief answer. 0.5. What is the ratio of the Number of refugees of Turkey in 1999 to that in 2005?
Keep it short and to the point. 1.17. What is the ratio of the Number of refugees of Caribbean small states in 1999 to that in 2006?
Offer a very short reply. 6.2. What is the ratio of the Number of refugees of Cambodia in 1999 to that in 2006?
Ensure brevity in your answer.  0.21. What is the ratio of the Number of refugees in Hong Kong in 1999 to that in 2006?
Make the answer very short. 0.5. What is the ratio of the Number of refugees in Turkey in 1999 to that in 2006?
Your response must be concise. 1.07. What is the ratio of the Number of refugees of Caribbean small states in 2000 to that in 2001?
Your answer should be very brief. 1.23. What is the ratio of the Number of refugees in Cambodia in 2000 to that in 2001?
Keep it short and to the point. 0.68. What is the ratio of the Number of refugees in Hong Kong in 2000 to that in 2001?
Your answer should be very brief. 0.71. What is the ratio of the Number of refugees of Turkey in 2000 to that in 2001?
Your answer should be compact. 0.89. What is the ratio of the Number of refugees of Caribbean small states in 2000 to that in 2002?
Make the answer very short. 1.32. What is the ratio of the Number of refugees in Cambodia in 2000 to that in 2002?
Your answer should be very brief. 0.17. What is the ratio of the Number of refugees of Hong Kong in 2000 to that in 2002?
Give a very brief answer. 0.66. What is the ratio of the Number of refugees of Caribbean small states in 2000 to that in 2003?
Your answer should be compact. 1.61. What is the ratio of the Number of refugees of Cambodia in 2000 to that in 2003?
Make the answer very short. 0.45. What is the ratio of the Number of refugees of Hong Kong in 2000 to that in 2003?
Provide a short and direct response. 0.52. What is the ratio of the Number of refugees in Turkey in 2000 to that in 2003?
Keep it short and to the point. 1.25. What is the ratio of the Number of refugees of Caribbean small states in 2000 to that in 2004?
Give a very brief answer. 1.9. What is the ratio of the Number of refugees in Cambodia in 2000 to that in 2004?
Your answer should be very brief. 0.09. What is the ratio of the Number of refugees of Hong Kong in 2000 to that in 2004?
Make the answer very short. 0.53. What is the ratio of the Number of refugees in Turkey in 2000 to that in 2004?
Offer a terse response. 1.02. What is the ratio of the Number of refugees of Caribbean small states in 2000 to that in 2005?
Keep it short and to the point. 2.22. What is the ratio of the Number of refugees of Cambodia in 2000 to that in 2005?
Your response must be concise. 0.27. What is the ratio of the Number of refugees in Hong Kong in 2000 to that in 2005?
Provide a short and direct response. 0.51. What is the ratio of the Number of refugees of Turkey in 2000 to that in 2005?
Your answer should be very brief. 1.29. What is the ratio of the Number of refugees of Caribbean small states in 2000 to that in 2006?
Give a very brief answer. 2.84. What is the ratio of the Number of refugees in Cambodia in 2000 to that in 2006?
Provide a succinct answer. 0.34. What is the ratio of the Number of refugees in Hong Kong in 2000 to that in 2006?
Keep it short and to the point. 0.51. What is the ratio of the Number of refugees in Turkey in 2000 to that in 2006?
Ensure brevity in your answer.  1.18. What is the ratio of the Number of refugees in Caribbean small states in 2001 to that in 2002?
Your response must be concise. 1.08. What is the ratio of the Number of refugees in Hong Kong in 2001 to that in 2002?
Offer a terse response. 0.93. What is the ratio of the Number of refugees of Turkey in 2001 to that in 2002?
Your answer should be very brief. 1.05. What is the ratio of the Number of refugees of Caribbean small states in 2001 to that in 2003?
Offer a very short reply. 1.31. What is the ratio of the Number of refugees in Cambodia in 2001 to that in 2003?
Provide a succinct answer. 0.66. What is the ratio of the Number of refugees in Hong Kong in 2001 to that in 2003?
Keep it short and to the point. 0.73. What is the ratio of the Number of refugees of Turkey in 2001 to that in 2003?
Give a very brief answer. 1.39. What is the ratio of the Number of refugees in Caribbean small states in 2001 to that in 2004?
Your answer should be very brief. 1.54. What is the ratio of the Number of refugees of Cambodia in 2001 to that in 2004?
Ensure brevity in your answer.  0.13. What is the ratio of the Number of refugees of Hong Kong in 2001 to that in 2004?
Your answer should be compact. 0.74. What is the ratio of the Number of refugees of Turkey in 2001 to that in 2004?
Make the answer very short. 1.14. What is the ratio of the Number of refugees in Caribbean small states in 2001 to that in 2005?
Provide a short and direct response. 1.81. What is the ratio of the Number of refugees in Cambodia in 2001 to that in 2005?
Provide a succinct answer. 0.39. What is the ratio of the Number of refugees of Hong Kong in 2001 to that in 2005?
Your answer should be compact. 0.72. What is the ratio of the Number of refugees of Turkey in 2001 to that in 2005?
Provide a short and direct response. 1.45. What is the ratio of the Number of refugees of Caribbean small states in 2001 to that in 2006?
Your answer should be very brief. 2.31. What is the ratio of the Number of refugees in Cambodia in 2001 to that in 2006?
Provide a short and direct response. 0.51. What is the ratio of the Number of refugees in Hong Kong in 2001 to that in 2006?
Your answer should be very brief. 0.72. What is the ratio of the Number of refugees of Turkey in 2001 to that in 2006?
Your answer should be compact. 1.32. What is the ratio of the Number of refugees in Caribbean small states in 2002 to that in 2003?
Make the answer very short. 1.22. What is the ratio of the Number of refugees in Cambodia in 2002 to that in 2003?
Make the answer very short. 2.63. What is the ratio of the Number of refugees of Hong Kong in 2002 to that in 2003?
Offer a terse response. 0.79. What is the ratio of the Number of refugees in Turkey in 2002 to that in 2003?
Keep it short and to the point. 1.33. What is the ratio of the Number of refugees in Caribbean small states in 2002 to that in 2004?
Provide a succinct answer. 1.43. What is the ratio of the Number of refugees of Cambodia in 2002 to that in 2004?
Your response must be concise. 0.52. What is the ratio of the Number of refugees of Hong Kong in 2002 to that in 2004?
Your answer should be very brief. 0.8. What is the ratio of the Number of refugees in Turkey in 2002 to that in 2004?
Your response must be concise. 1.09. What is the ratio of the Number of refugees of Caribbean small states in 2002 to that in 2005?
Ensure brevity in your answer.  1.68. What is the ratio of the Number of refugees in Cambodia in 2002 to that in 2005?
Provide a short and direct response. 1.57. What is the ratio of the Number of refugees of Hong Kong in 2002 to that in 2005?
Offer a very short reply. 0.77. What is the ratio of the Number of refugees in Turkey in 2002 to that in 2005?
Make the answer very short. 1.38. What is the ratio of the Number of refugees in Caribbean small states in 2002 to that in 2006?
Ensure brevity in your answer.  2.15. What is the ratio of the Number of refugees of Cambodia in 2002 to that in 2006?
Your answer should be very brief. 2.02. What is the ratio of the Number of refugees in Hong Kong in 2002 to that in 2006?
Provide a succinct answer. 0.77. What is the ratio of the Number of refugees of Turkey in 2002 to that in 2006?
Your response must be concise. 1.25. What is the ratio of the Number of refugees in Caribbean small states in 2003 to that in 2004?
Your response must be concise. 1.18. What is the ratio of the Number of refugees of Cambodia in 2003 to that in 2004?
Offer a terse response. 0.2. What is the ratio of the Number of refugees in Hong Kong in 2003 to that in 2004?
Your answer should be compact. 1.02. What is the ratio of the Number of refugees in Turkey in 2003 to that in 2004?
Your answer should be very brief. 0.82. What is the ratio of the Number of refugees in Caribbean small states in 2003 to that in 2005?
Provide a succinct answer. 1.38. What is the ratio of the Number of refugees of Cambodia in 2003 to that in 2005?
Your response must be concise. 0.6. What is the ratio of the Number of refugees of Hong Kong in 2003 to that in 2005?
Offer a very short reply. 0.98. What is the ratio of the Number of refugees in Turkey in 2003 to that in 2005?
Give a very brief answer. 1.04. What is the ratio of the Number of refugees of Caribbean small states in 2003 to that in 2006?
Offer a terse response. 1.76. What is the ratio of the Number of refugees of Cambodia in 2003 to that in 2006?
Your response must be concise. 0.77. What is the ratio of the Number of refugees of Hong Kong in 2003 to that in 2006?
Ensure brevity in your answer.  0.98. What is the ratio of the Number of refugees in Turkey in 2003 to that in 2006?
Provide a short and direct response. 0.95. What is the ratio of the Number of refugees of Caribbean small states in 2004 to that in 2005?
Make the answer very short. 1.17. What is the ratio of the Number of refugees in Cambodia in 2004 to that in 2005?
Keep it short and to the point. 3.01. What is the ratio of the Number of refugees in Hong Kong in 2004 to that in 2005?
Ensure brevity in your answer.  0.97. What is the ratio of the Number of refugees of Turkey in 2004 to that in 2005?
Keep it short and to the point. 1.26. What is the ratio of the Number of refugees in Cambodia in 2004 to that in 2006?
Your answer should be compact. 3.86. What is the ratio of the Number of refugees of Hong Kong in 2004 to that in 2006?
Give a very brief answer. 0.96. What is the ratio of the Number of refugees of Turkey in 2004 to that in 2006?
Offer a terse response. 1.15. What is the ratio of the Number of refugees in Caribbean small states in 2005 to that in 2006?
Offer a very short reply. 1.28. What is the ratio of the Number of refugees of Cambodia in 2005 to that in 2006?
Keep it short and to the point. 1.28. What is the ratio of the Number of refugees in Turkey in 2005 to that in 2006?
Give a very brief answer. 0.91. What is the difference between the highest and the second highest Number of refugees of Caribbean small states?
Offer a terse response. 1640. What is the difference between the highest and the second highest Number of refugees in Cambodia?
Provide a succinct answer. 182. What is the difference between the highest and the second highest Number of refugees of Hong Kong?
Provide a succinct answer. 6. What is the difference between the highest and the second highest Number of refugees in Turkey?
Make the answer very short. 171. What is the difference between the highest and the lowest Number of refugees of Caribbean small states?
Give a very brief answer. 2540. What is the difference between the highest and the lowest Number of refugees in Cambodia?
Your response must be concise. 361. What is the difference between the highest and the lowest Number of refugees of Hong Kong?
Provide a short and direct response. 966. What is the difference between the highest and the lowest Number of refugees in Turkey?
Offer a very short reply. 1073. 